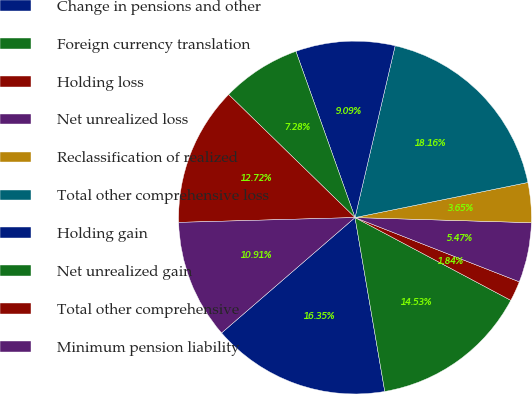Convert chart to OTSL. <chart><loc_0><loc_0><loc_500><loc_500><pie_chart><fcel>Change in pensions and other<fcel>Foreign currency translation<fcel>Holding loss<fcel>Net unrealized loss<fcel>Reclassification of realized<fcel>Total other comprehensive loss<fcel>Holding gain<fcel>Net unrealized gain<fcel>Total other comprehensive<fcel>Minimum pension liability<nl><fcel>16.35%<fcel>14.53%<fcel>1.84%<fcel>5.47%<fcel>3.65%<fcel>18.16%<fcel>9.09%<fcel>7.28%<fcel>12.72%<fcel>10.91%<nl></chart> 